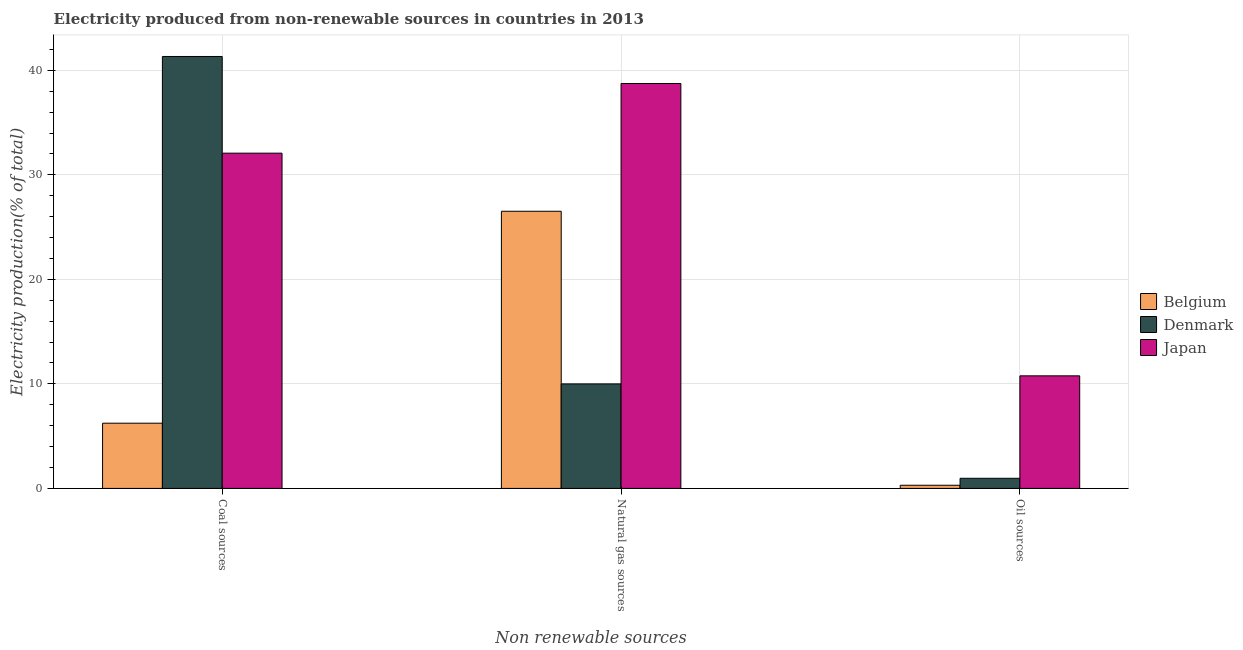Are the number of bars on each tick of the X-axis equal?
Ensure brevity in your answer.  Yes. How many bars are there on the 1st tick from the left?
Offer a very short reply. 3. How many bars are there on the 2nd tick from the right?
Your answer should be compact. 3. What is the label of the 2nd group of bars from the left?
Offer a very short reply. Natural gas sources. What is the percentage of electricity produced by natural gas in Japan?
Ensure brevity in your answer.  38.74. Across all countries, what is the maximum percentage of electricity produced by natural gas?
Your answer should be very brief. 38.74. Across all countries, what is the minimum percentage of electricity produced by natural gas?
Keep it short and to the point. 10. In which country was the percentage of electricity produced by oil sources maximum?
Provide a short and direct response. Japan. In which country was the percentage of electricity produced by oil sources minimum?
Your answer should be very brief. Belgium. What is the total percentage of electricity produced by oil sources in the graph?
Offer a very short reply. 12.04. What is the difference between the percentage of electricity produced by coal in Belgium and that in Japan?
Your answer should be very brief. -25.83. What is the difference between the percentage of electricity produced by coal in Belgium and the percentage of electricity produced by oil sources in Japan?
Ensure brevity in your answer.  -4.53. What is the average percentage of electricity produced by natural gas per country?
Make the answer very short. 25.09. What is the difference between the percentage of electricity produced by coal and percentage of electricity produced by oil sources in Japan?
Ensure brevity in your answer.  21.3. In how many countries, is the percentage of electricity produced by oil sources greater than 12 %?
Provide a succinct answer. 0. What is the ratio of the percentage of electricity produced by coal in Belgium to that in Denmark?
Your answer should be very brief. 0.15. What is the difference between the highest and the second highest percentage of electricity produced by natural gas?
Offer a terse response. 12.22. What is the difference between the highest and the lowest percentage of electricity produced by coal?
Give a very brief answer. 35.09. In how many countries, is the percentage of electricity produced by natural gas greater than the average percentage of electricity produced by natural gas taken over all countries?
Give a very brief answer. 2. What does the 1st bar from the right in Natural gas sources represents?
Your response must be concise. Japan. Are all the bars in the graph horizontal?
Ensure brevity in your answer.  No. How many countries are there in the graph?
Offer a terse response. 3. Are the values on the major ticks of Y-axis written in scientific E-notation?
Your answer should be very brief. No. Does the graph contain grids?
Ensure brevity in your answer.  Yes. How many legend labels are there?
Offer a terse response. 3. What is the title of the graph?
Provide a succinct answer. Electricity produced from non-renewable sources in countries in 2013. Does "Puerto Rico" appear as one of the legend labels in the graph?
Offer a very short reply. No. What is the label or title of the X-axis?
Give a very brief answer. Non renewable sources. What is the label or title of the Y-axis?
Provide a short and direct response. Electricity production(% of total). What is the Electricity production(% of total) of Belgium in Coal sources?
Offer a terse response. 6.24. What is the Electricity production(% of total) of Denmark in Coal sources?
Give a very brief answer. 41.33. What is the Electricity production(% of total) in Japan in Coal sources?
Offer a terse response. 32.07. What is the Electricity production(% of total) in Belgium in Natural gas sources?
Provide a short and direct response. 26.52. What is the Electricity production(% of total) in Denmark in Natural gas sources?
Provide a short and direct response. 10. What is the Electricity production(% of total) in Japan in Natural gas sources?
Make the answer very short. 38.74. What is the Electricity production(% of total) of Belgium in Oil sources?
Provide a short and direct response. 0.3. What is the Electricity production(% of total) of Denmark in Oil sources?
Offer a very short reply. 0.97. What is the Electricity production(% of total) of Japan in Oil sources?
Offer a terse response. 10.77. Across all Non renewable sources, what is the maximum Electricity production(% of total) in Belgium?
Make the answer very short. 26.52. Across all Non renewable sources, what is the maximum Electricity production(% of total) in Denmark?
Make the answer very short. 41.33. Across all Non renewable sources, what is the maximum Electricity production(% of total) of Japan?
Offer a terse response. 38.74. Across all Non renewable sources, what is the minimum Electricity production(% of total) in Belgium?
Your response must be concise. 0.3. Across all Non renewable sources, what is the minimum Electricity production(% of total) in Denmark?
Give a very brief answer. 0.97. Across all Non renewable sources, what is the minimum Electricity production(% of total) of Japan?
Offer a very short reply. 10.77. What is the total Electricity production(% of total) of Belgium in the graph?
Your response must be concise. 33.06. What is the total Electricity production(% of total) of Denmark in the graph?
Your answer should be very brief. 52.29. What is the total Electricity production(% of total) of Japan in the graph?
Give a very brief answer. 81.59. What is the difference between the Electricity production(% of total) in Belgium in Coal sources and that in Natural gas sources?
Your answer should be very brief. -20.28. What is the difference between the Electricity production(% of total) in Denmark in Coal sources and that in Natural gas sources?
Your answer should be very brief. 31.33. What is the difference between the Electricity production(% of total) in Japan in Coal sources and that in Natural gas sources?
Ensure brevity in your answer.  -6.67. What is the difference between the Electricity production(% of total) in Belgium in Coal sources and that in Oil sources?
Your answer should be compact. 5.94. What is the difference between the Electricity production(% of total) of Denmark in Coal sources and that in Oil sources?
Your answer should be compact. 40.36. What is the difference between the Electricity production(% of total) in Japan in Coal sources and that in Oil sources?
Make the answer very short. 21.3. What is the difference between the Electricity production(% of total) of Belgium in Natural gas sources and that in Oil sources?
Your response must be concise. 26.21. What is the difference between the Electricity production(% of total) in Denmark in Natural gas sources and that in Oil sources?
Give a very brief answer. 9.03. What is the difference between the Electricity production(% of total) in Japan in Natural gas sources and that in Oil sources?
Offer a very short reply. 27.97. What is the difference between the Electricity production(% of total) of Belgium in Coal sources and the Electricity production(% of total) of Denmark in Natural gas sources?
Offer a terse response. -3.76. What is the difference between the Electricity production(% of total) of Belgium in Coal sources and the Electricity production(% of total) of Japan in Natural gas sources?
Provide a short and direct response. -32.5. What is the difference between the Electricity production(% of total) in Denmark in Coal sources and the Electricity production(% of total) in Japan in Natural gas sources?
Your response must be concise. 2.58. What is the difference between the Electricity production(% of total) in Belgium in Coal sources and the Electricity production(% of total) in Denmark in Oil sources?
Your response must be concise. 5.27. What is the difference between the Electricity production(% of total) of Belgium in Coal sources and the Electricity production(% of total) of Japan in Oil sources?
Your answer should be very brief. -4.53. What is the difference between the Electricity production(% of total) in Denmark in Coal sources and the Electricity production(% of total) in Japan in Oil sources?
Offer a very short reply. 30.56. What is the difference between the Electricity production(% of total) in Belgium in Natural gas sources and the Electricity production(% of total) in Denmark in Oil sources?
Make the answer very short. 25.55. What is the difference between the Electricity production(% of total) in Belgium in Natural gas sources and the Electricity production(% of total) in Japan in Oil sources?
Provide a succinct answer. 15.75. What is the difference between the Electricity production(% of total) in Denmark in Natural gas sources and the Electricity production(% of total) in Japan in Oil sources?
Keep it short and to the point. -0.77. What is the average Electricity production(% of total) in Belgium per Non renewable sources?
Offer a terse response. 11.02. What is the average Electricity production(% of total) in Denmark per Non renewable sources?
Keep it short and to the point. 17.43. What is the average Electricity production(% of total) in Japan per Non renewable sources?
Offer a very short reply. 27.2. What is the difference between the Electricity production(% of total) of Belgium and Electricity production(% of total) of Denmark in Coal sources?
Your answer should be very brief. -35.09. What is the difference between the Electricity production(% of total) in Belgium and Electricity production(% of total) in Japan in Coal sources?
Offer a terse response. -25.83. What is the difference between the Electricity production(% of total) in Denmark and Electricity production(% of total) in Japan in Coal sources?
Provide a short and direct response. 9.25. What is the difference between the Electricity production(% of total) of Belgium and Electricity production(% of total) of Denmark in Natural gas sources?
Your answer should be compact. 16.52. What is the difference between the Electricity production(% of total) in Belgium and Electricity production(% of total) in Japan in Natural gas sources?
Your response must be concise. -12.22. What is the difference between the Electricity production(% of total) in Denmark and Electricity production(% of total) in Japan in Natural gas sources?
Your answer should be compact. -28.74. What is the difference between the Electricity production(% of total) in Belgium and Electricity production(% of total) in Denmark in Oil sources?
Ensure brevity in your answer.  -0.67. What is the difference between the Electricity production(% of total) in Belgium and Electricity production(% of total) in Japan in Oil sources?
Make the answer very short. -10.47. What is the difference between the Electricity production(% of total) of Denmark and Electricity production(% of total) of Japan in Oil sources?
Offer a terse response. -9.8. What is the ratio of the Electricity production(% of total) in Belgium in Coal sources to that in Natural gas sources?
Your answer should be very brief. 0.24. What is the ratio of the Electricity production(% of total) of Denmark in Coal sources to that in Natural gas sources?
Your response must be concise. 4.13. What is the ratio of the Electricity production(% of total) in Japan in Coal sources to that in Natural gas sources?
Ensure brevity in your answer.  0.83. What is the ratio of the Electricity production(% of total) in Belgium in Coal sources to that in Oil sources?
Provide a succinct answer. 20.61. What is the ratio of the Electricity production(% of total) of Denmark in Coal sources to that in Oil sources?
Provide a short and direct response. 42.66. What is the ratio of the Electricity production(% of total) in Japan in Coal sources to that in Oil sources?
Ensure brevity in your answer.  2.98. What is the ratio of the Electricity production(% of total) of Belgium in Natural gas sources to that in Oil sources?
Offer a very short reply. 87.56. What is the ratio of the Electricity production(% of total) in Denmark in Natural gas sources to that in Oil sources?
Keep it short and to the point. 10.32. What is the ratio of the Electricity production(% of total) in Japan in Natural gas sources to that in Oil sources?
Your answer should be compact. 3.6. What is the difference between the highest and the second highest Electricity production(% of total) of Belgium?
Make the answer very short. 20.28. What is the difference between the highest and the second highest Electricity production(% of total) in Denmark?
Your answer should be compact. 31.33. What is the difference between the highest and the second highest Electricity production(% of total) of Japan?
Ensure brevity in your answer.  6.67. What is the difference between the highest and the lowest Electricity production(% of total) in Belgium?
Your answer should be very brief. 26.21. What is the difference between the highest and the lowest Electricity production(% of total) in Denmark?
Ensure brevity in your answer.  40.36. What is the difference between the highest and the lowest Electricity production(% of total) of Japan?
Your response must be concise. 27.97. 